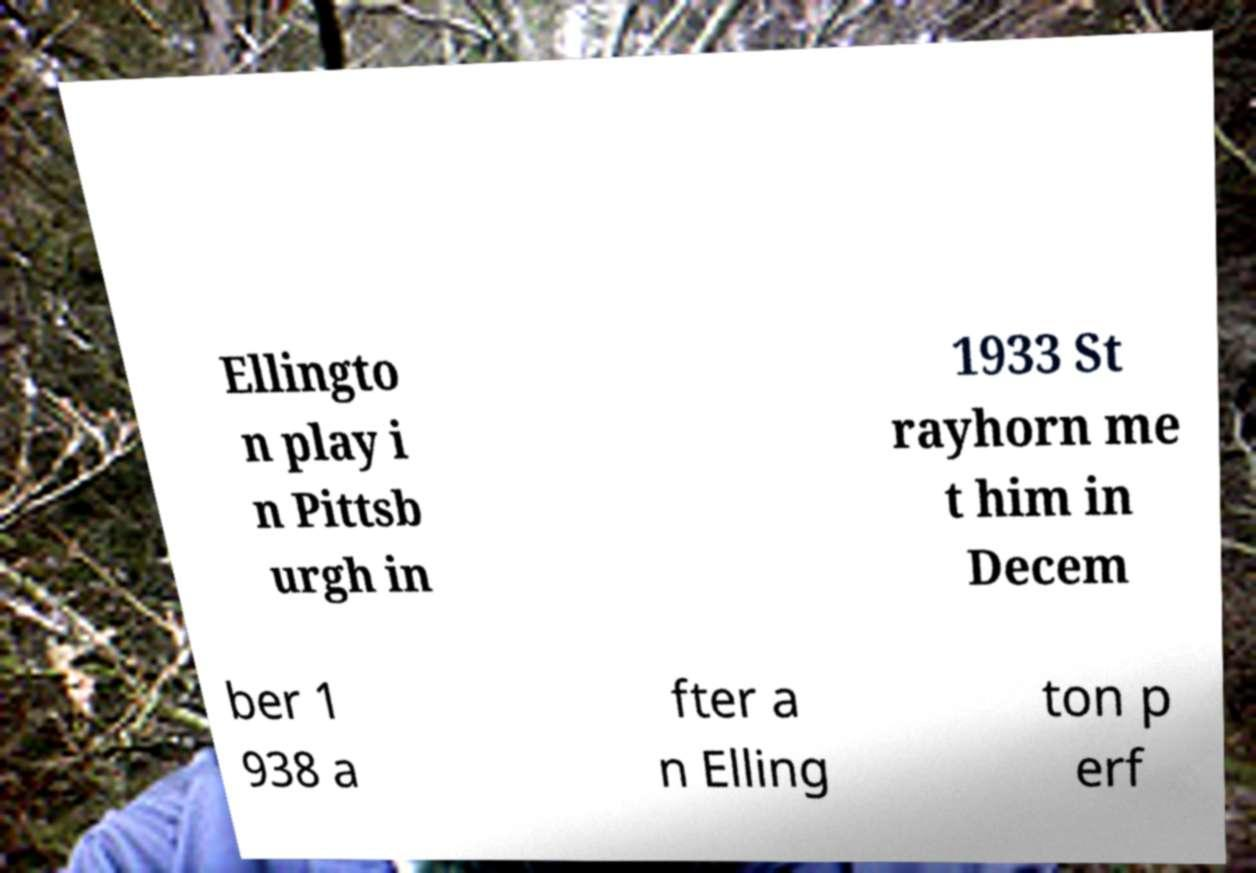Can you read and provide the text displayed in the image?This photo seems to have some interesting text. Can you extract and type it out for me? Ellingto n play i n Pittsb urgh in 1933 St rayhorn me t him in Decem ber 1 938 a fter a n Elling ton p erf 